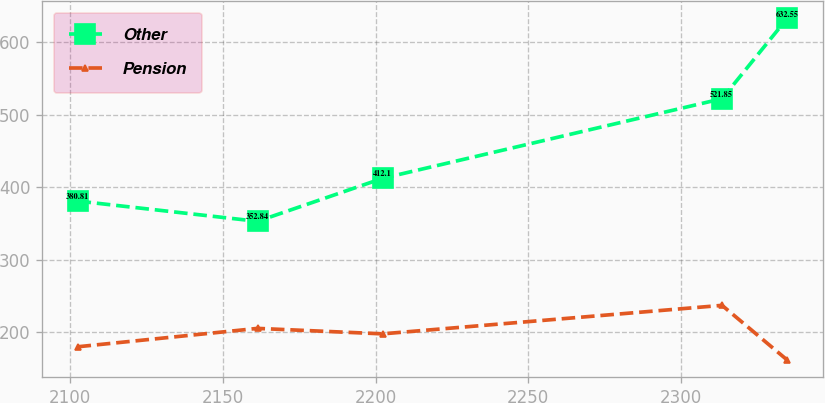Convert chart to OTSL. <chart><loc_0><loc_0><loc_500><loc_500><line_chart><ecel><fcel>Other<fcel>Pension<nl><fcel>2102.43<fcel>380.81<fcel>179.92<nl><fcel>2161.36<fcel>352.84<fcel>205.28<nl><fcel>2202.3<fcel>412.1<fcel>197.75<nl><fcel>2313.42<fcel>521.85<fcel>237.05<nl><fcel>2334.74<fcel>632.55<fcel>161.73<nl></chart> 